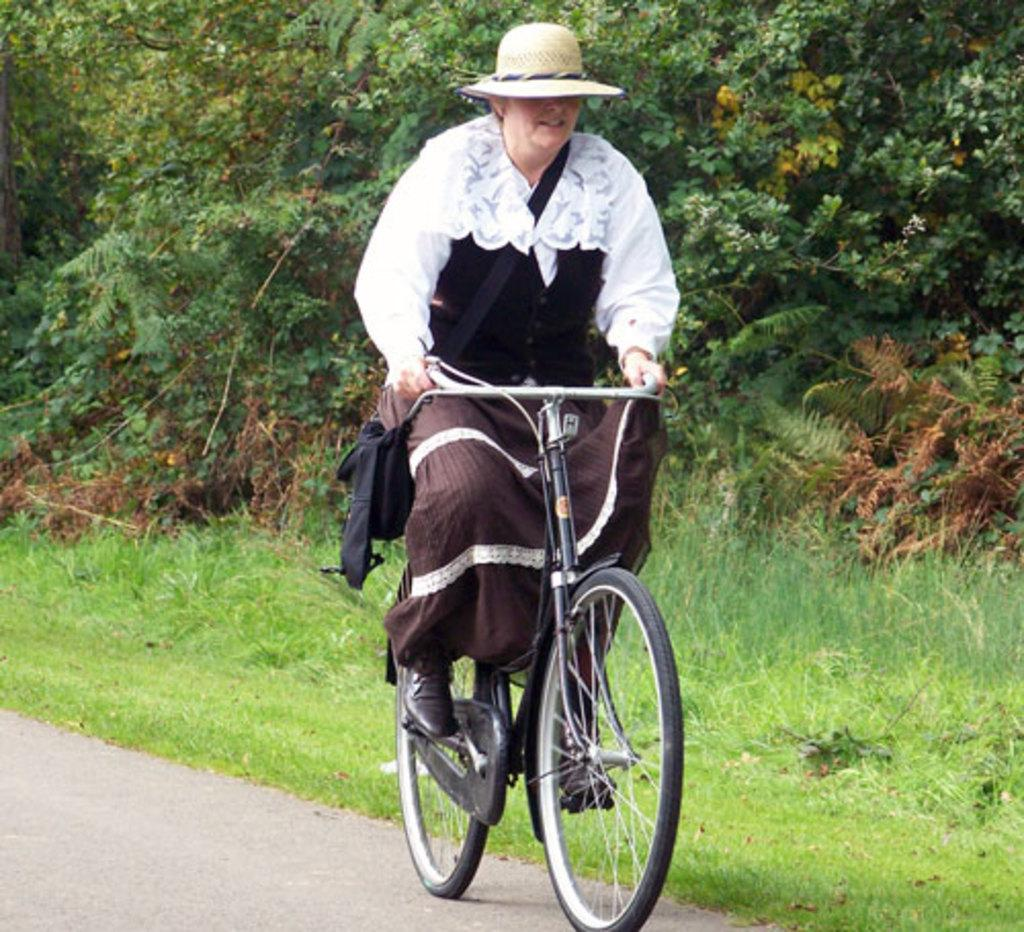What can be seen beside the road in the image? There are plants and trees beside the road in the image. Can you describe the person in the image? The person in the image is wearing clothes and riding a bicycle. How many bikes are being waxed in the image? There are no bikes being waxed in the image. What number is written on the person's shirt in the image? There is no number visible on the person's shirt in the image. 